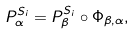<formula> <loc_0><loc_0><loc_500><loc_500>P _ { \alpha } ^ { S _ { i } } = P _ { \beta } ^ { S _ { i } } \circ \Phi _ { \beta , \alpha } ,</formula> 